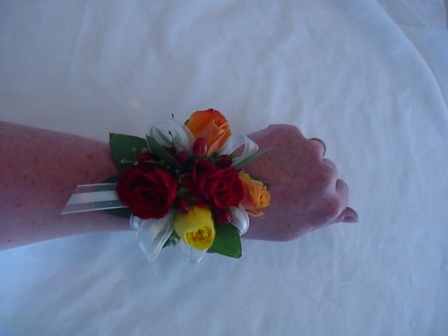What do you think about the artistic elements of this image? The artistic elements of this image are quite striking. The centered composition of the corsage, prominently featuring vibrant colors against a stark white background, draws the viewer's attention immediately. The contrast between the colorful roses and the white tablecloth adds depth and highlights the freshness of the flowers. The ribbons add an element of texture and movement, guiding the viewer's eye across the image. The gentle positioning of the hand suggests tranquility and elegance, emphasizing the formal nature of the event. Overall, the image captures a beautiful blend of color, texture, and emotion through its carefully arranged elements. 